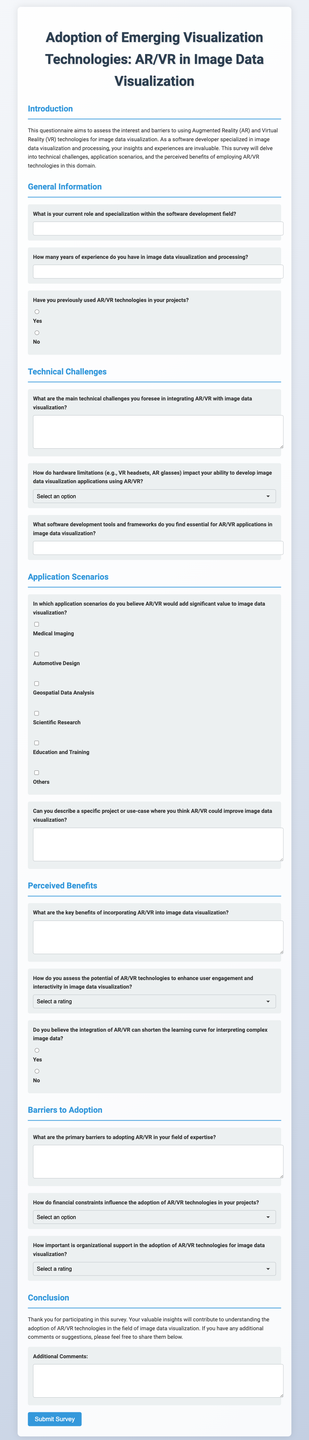What is the title of the questionnaire? The title of the questionnaire is provided at the top of the document, which outlines the focus on AR/VR in image data visualization.
Answer: Adoption of Emerging Visualization Technologies: AR/VR in Image Data Visualization How many years of experience does the questionnaire ask for? The questionnaire specifically asks for a numerical response regarding years of experience in image data visualization and processing.
Answer: years What are the two technologies mentioned in the introduction? The introduction mentions the technologies that the questionnaire focuses on.
Answer: Augmented Reality and Virtual Reality How is user engagement rated in the questionnaire? The questionnaire includes a scale for assessing the potential enhancement of user engagement and interactivity with specified levels.
Answer: 1 to 5 What type of scenarios are provided for application of AR/VR? The questionnaire lists various scenarios for potential application of AR/VR in image data visualization where additional value could be added.
Answer: Medical Imaging, Automotive Design, Geospatial Data Analysis, Scientific Research, Education and Training How many main sections does the questionnaire contain? The organization of the questionnaire into distinct themes allows for clear sectioning, indicating the different topics covered.
Answer: five 